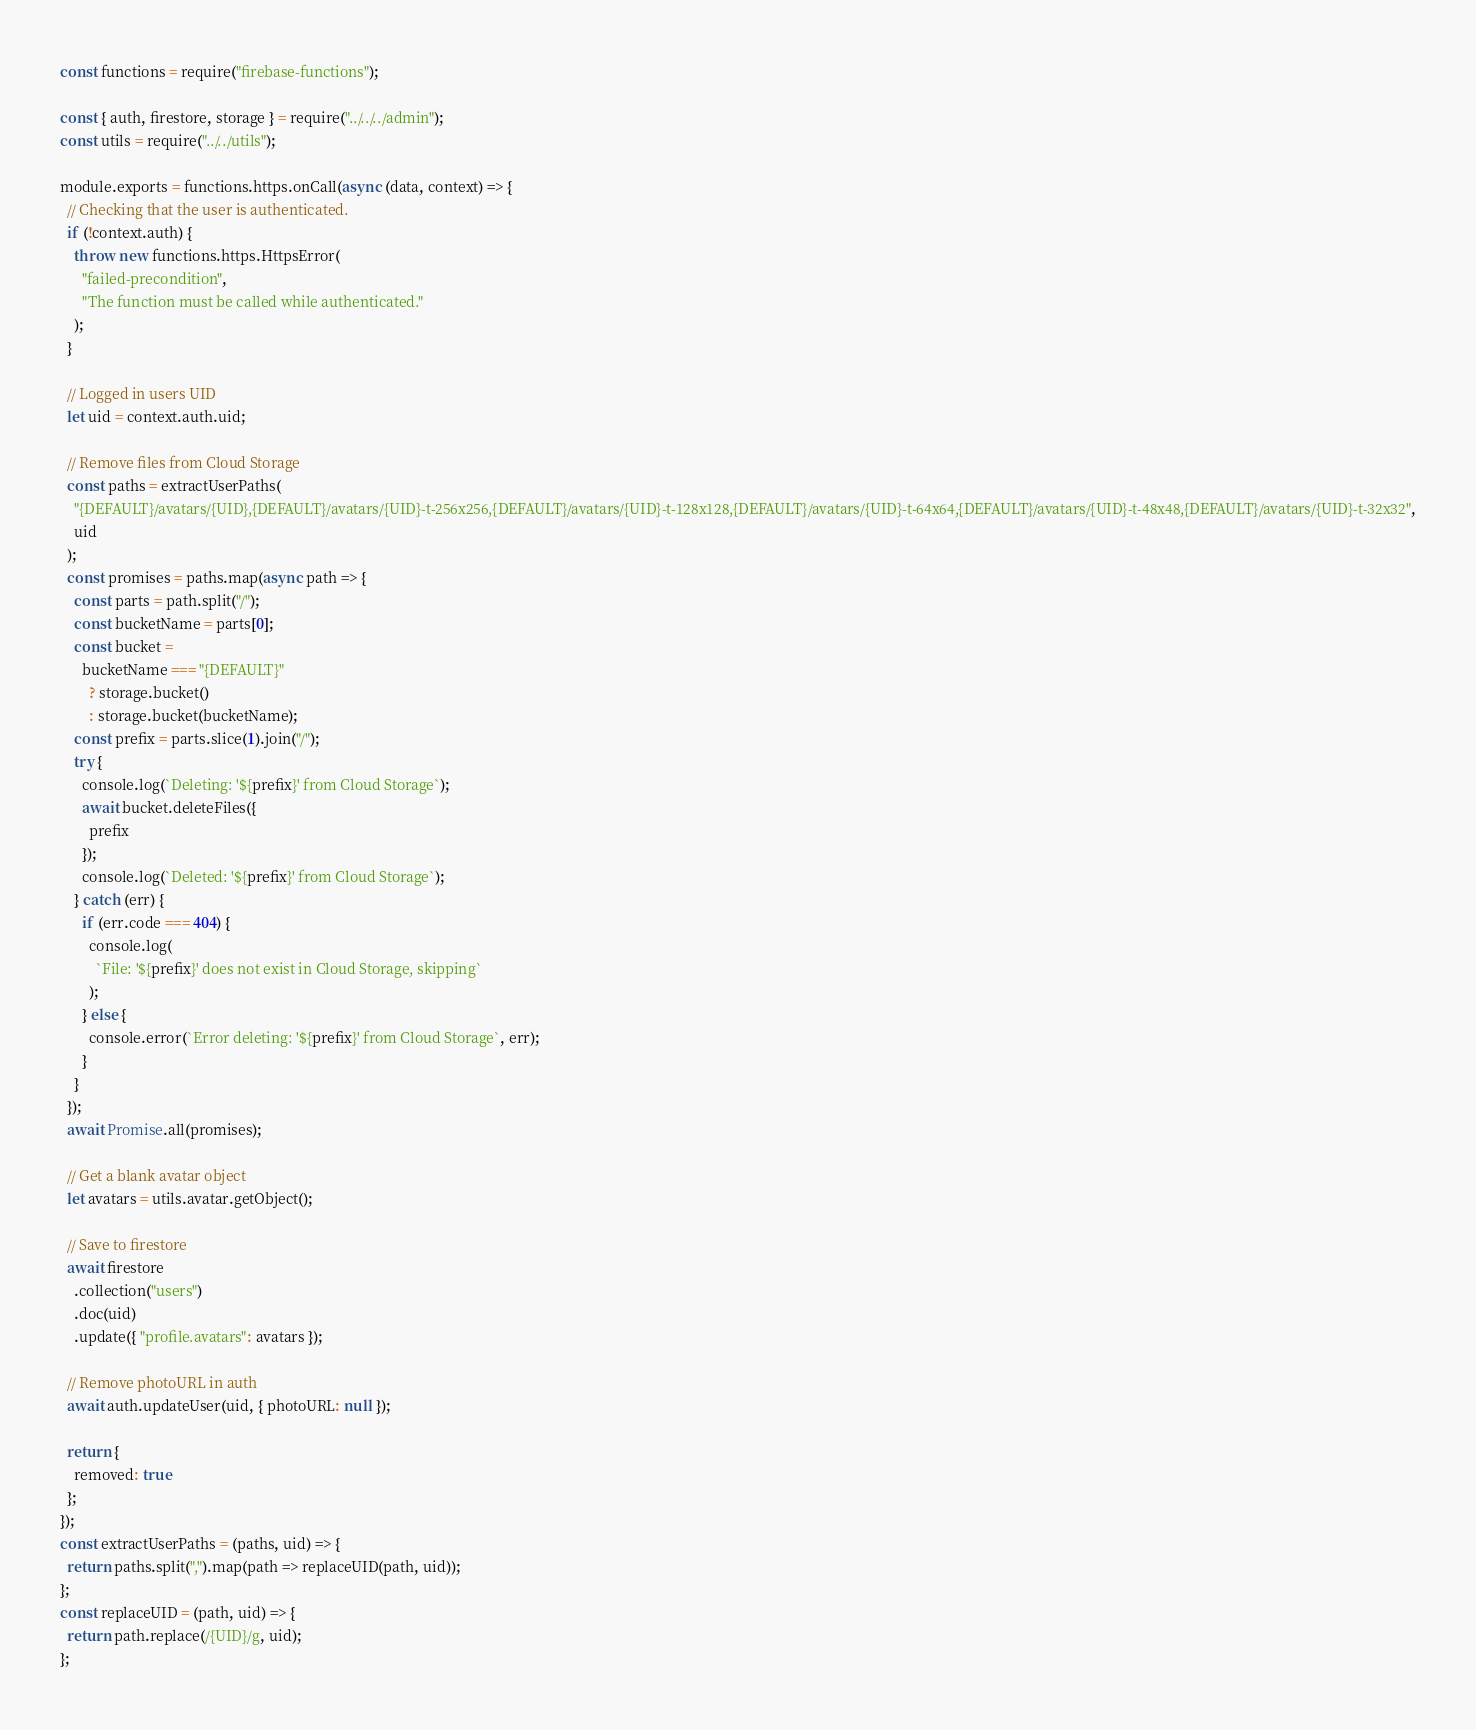Convert code to text. <code><loc_0><loc_0><loc_500><loc_500><_JavaScript_>const functions = require("firebase-functions");

const { auth, firestore, storage } = require("../../../admin");
const utils = require("../../utils");

module.exports = functions.https.onCall(async (data, context) => {
  // Checking that the user is authenticated.
  if (!context.auth) {
    throw new functions.https.HttpsError(
      "failed-precondition",
      "The function must be called while authenticated."
    );
  }

  // Logged in users UID
  let uid = context.auth.uid;

  // Remove files from Cloud Storage
  const paths = extractUserPaths(
    "{DEFAULT}/avatars/{UID},{DEFAULT}/avatars/{UID}-t-256x256,{DEFAULT}/avatars/{UID}-t-128x128,{DEFAULT}/avatars/{UID}-t-64x64,{DEFAULT}/avatars/{UID}-t-48x48,{DEFAULT}/avatars/{UID}-t-32x32",
    uid
  );
  const promises = paths.map(async path => {
    const parts = path.split("/");
    const bucketName = parts[0];
    const bucket =
      bucketName === "{DEFAULT}"
        ? storage.bucket()
        : storage.bucket(bucketName);
    const prefix = parts.slice(1).join("/");
    try {
      console.log(`Deleting: '${prefix}' from Cloud Storage`);
      await bucket.deleteFiles({
        prefix
      });
      console.log(`Deleted: '${prefix}' from Cloud Storage`);
    } catch (err) {
      if (err.code === 404) {
        console.log(
          `File: '${prefix}' does not exist in Cloud Storage, skipping`
        );
      } else {
        console.error(`Error deleting: '${prefix}' from Cloud Storage`, err);
      }
    }
  });
  await Promise.all(promises);

  // Get a blank avatar object
  let avatars = utils.avatar.getObject();

  // Save to firestore
  await firestore
    .collection("users")
    .doc(uid)
    .update({ "profile.avatars": avatars });

  // Remove photoURL in auth
  await auth.updateUser(uid, { photoURL: null });

  return {
    removed: true
  };
});
const extractUserPaths = (paths, uid) => {
  return paths.split(",").map(path => replaceUID(path, uid));
};
const replaceUID = (path, uid) => {
  return path.replace(/{UID}/g, uid);
};
</code> 